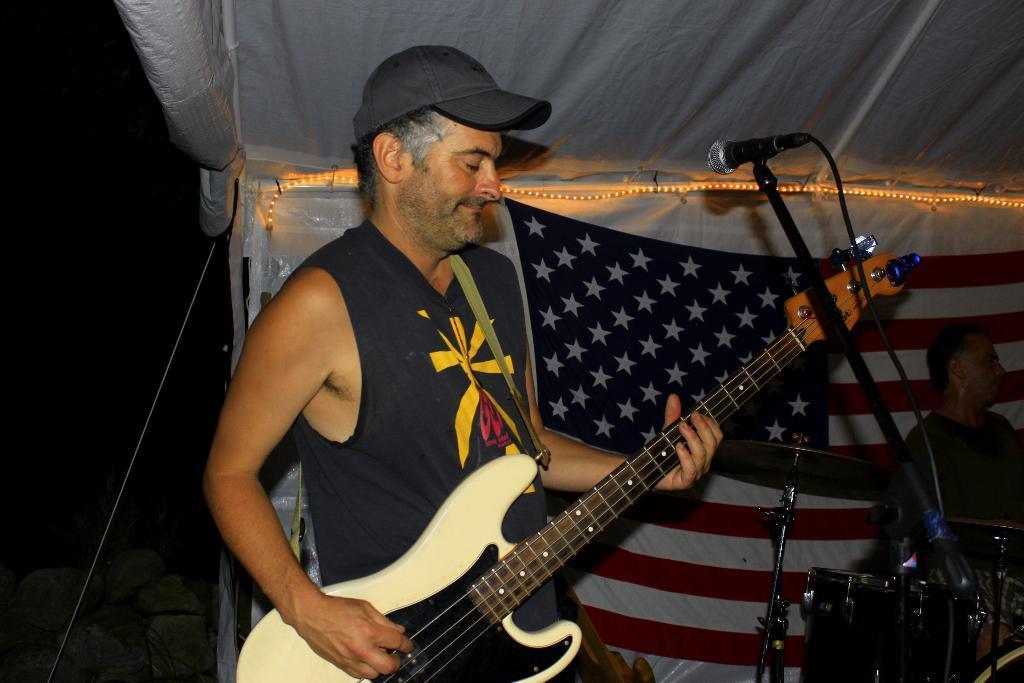Please provide a concise description of this image. In this image I see a man who is holding a guitar and he is in front of a mic. In the background I see the flag and a man with musical Instrument. 